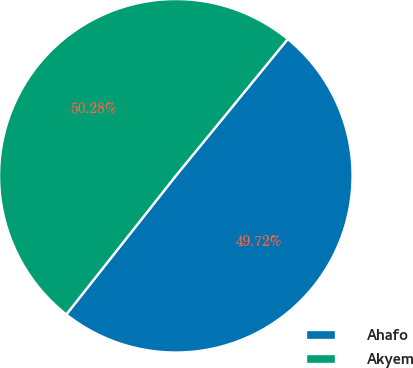Convert chart to OTSL. <chart><loc_0><loc_0><loc_500><loc_500><pie_chart><fcel>Ahafo<fcel>Akyem<nl><fcel>49.72%<fcel>50.28%<nl></chart> 